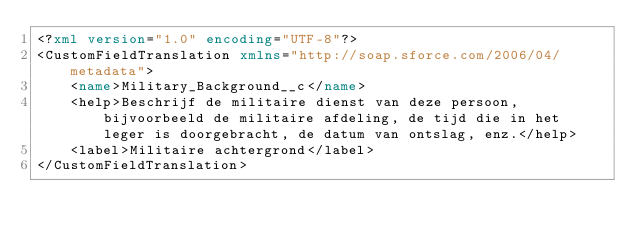Convert code to text. <code><loc_0><loc_0><loc_500><loc_500><_XML_><?xml version="1.0" encoding="UTF-8"?>
<CustomFieldTranslation xmlns="http://soap.sforce.com/2006/04/metadata">
    <name>Military_Background__c</name>
    <help>Beschrijf de militaire dienst van deze persoon, bijvoorbeeld de militaire afdeling, de tijd die in het leger is doorgebracht, de datum van ontslag, enz.</help>
    <label>Militaire achtergrond</label>
</CustomFieldTranslation>
</code> 